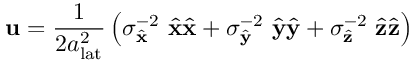<formula> <loc_0><loc_0><loc_500><loc_500>u = \frac { 1 } { 2 a _ { l a t } ^ { 2 } } \left ( \sigma _ { \hat { x } } ^ { - 2 } \hat { x } \hat { x } + \sigma _ { \hat { y } } ^ { - 2 } \hat { y } \hat { y } + \sigma _ { \hat { z } } ^ { - 2 } \hat { z } \hat { z } \right )</formula> 